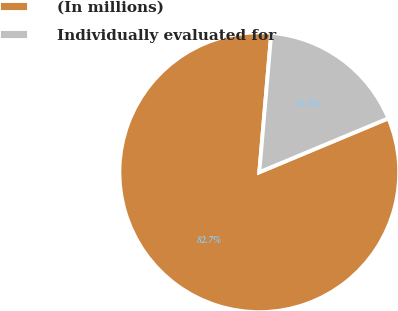Convert chart to OTSL. <chart><loc_0><loc_0><loc_500><loc_500><pie_chart><fcel>(In millions)<fcel>Individually evaluated for<nl><fcel>82.66%<fcel>17.34%<nl></chart> 